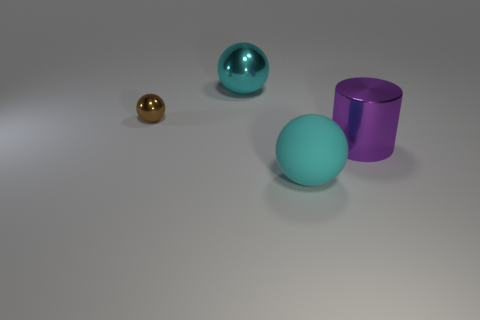Subtract all cylinders. How many objects are left? 3 Add 1 metallic spheres. How many objects exist? 5 Subtract all metallic things. Subtract all red shiny cylinders. How many objects are left? 1 Add 3 rubber objects. How many rubber objects are left? 4 Add 2 big rubber objects. How many big rubber objects exist? 3 Subtract 0 yellow cubes. How many objects are left? 4 